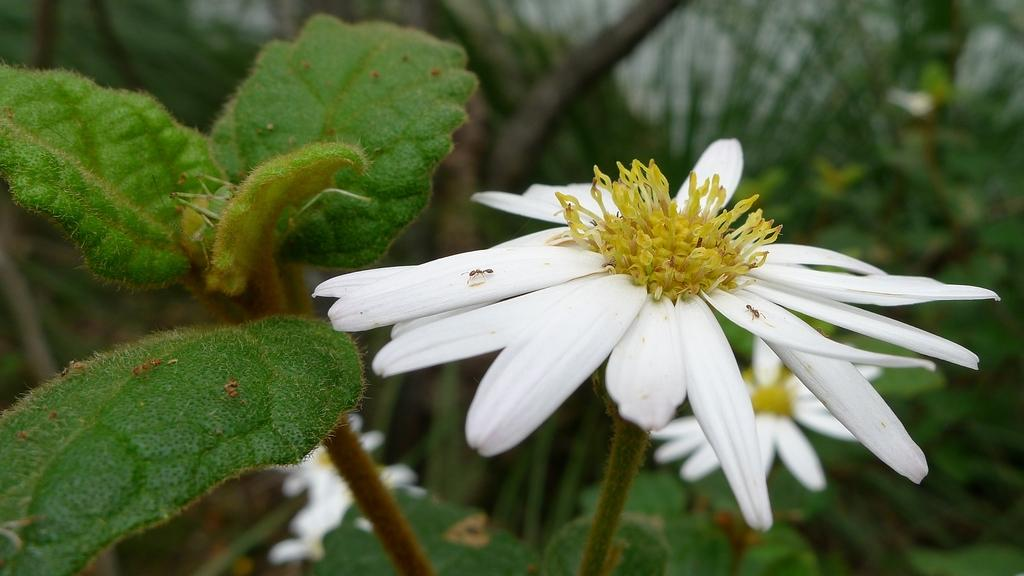What type of flower can be seen in the image? There is a white flower on a plant in the image. What color are the leaves on the left side of the image? The leaves on the left side of the image are green. What song is being played in the background of the image? There is no information about a song being played in the image, as it only features a white flower and green leaves. 